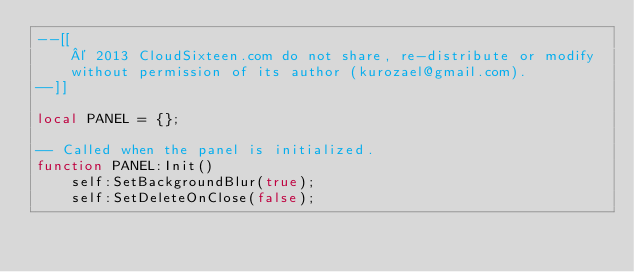<code> <loc_0><loc_0><loc_500><loc_500><_Lua_>--[[
	© 2013 CloudSixteen.com do not share, re-distribute or modify
	without permission of its author (kurozael@gmail.com).
--]]

local PANEL = {};

-- Called when the panel is initialized.
function PANEL:Init()
	self:SetBackgroundBlur(true);
	self:SetDeleteOnClose(false);
	</code> 